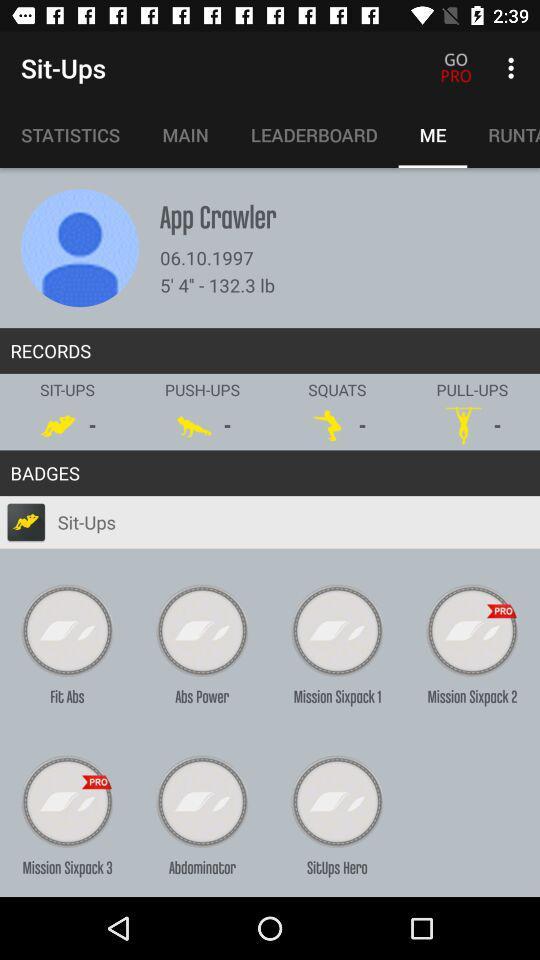What is the weight of the user? The weight of the user is 132.3 lb. 